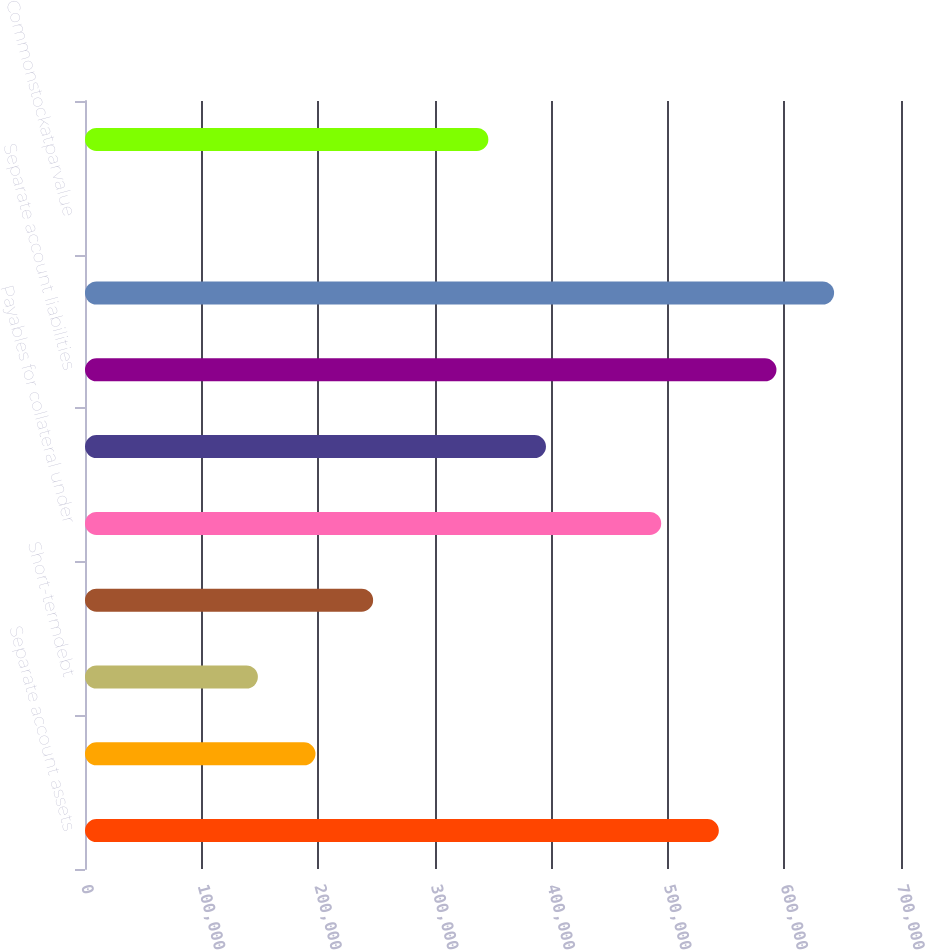Convert chart. <chart><loc_0><loc_0><loc_500><loc_500><bar_chart><fcel>Separate account assets<fcel>Property and casualty<fcel>Short-termdebt<fcel>Long-termdebt<fcel>Payables for collateral under<fcel>Other<fcel>Separate account liabilities<fcel>Total liabilities(2)<fcel>Commonstockatparvalue<fcel>Additional paid-in capital<nl><fcel>543739<fcel>197728<fcel>148298<fcel>247158<fcel>494309<fcel>395449<fcel>593169<fcel>642599<fcel>8<fcel>346019<nl></chart> 